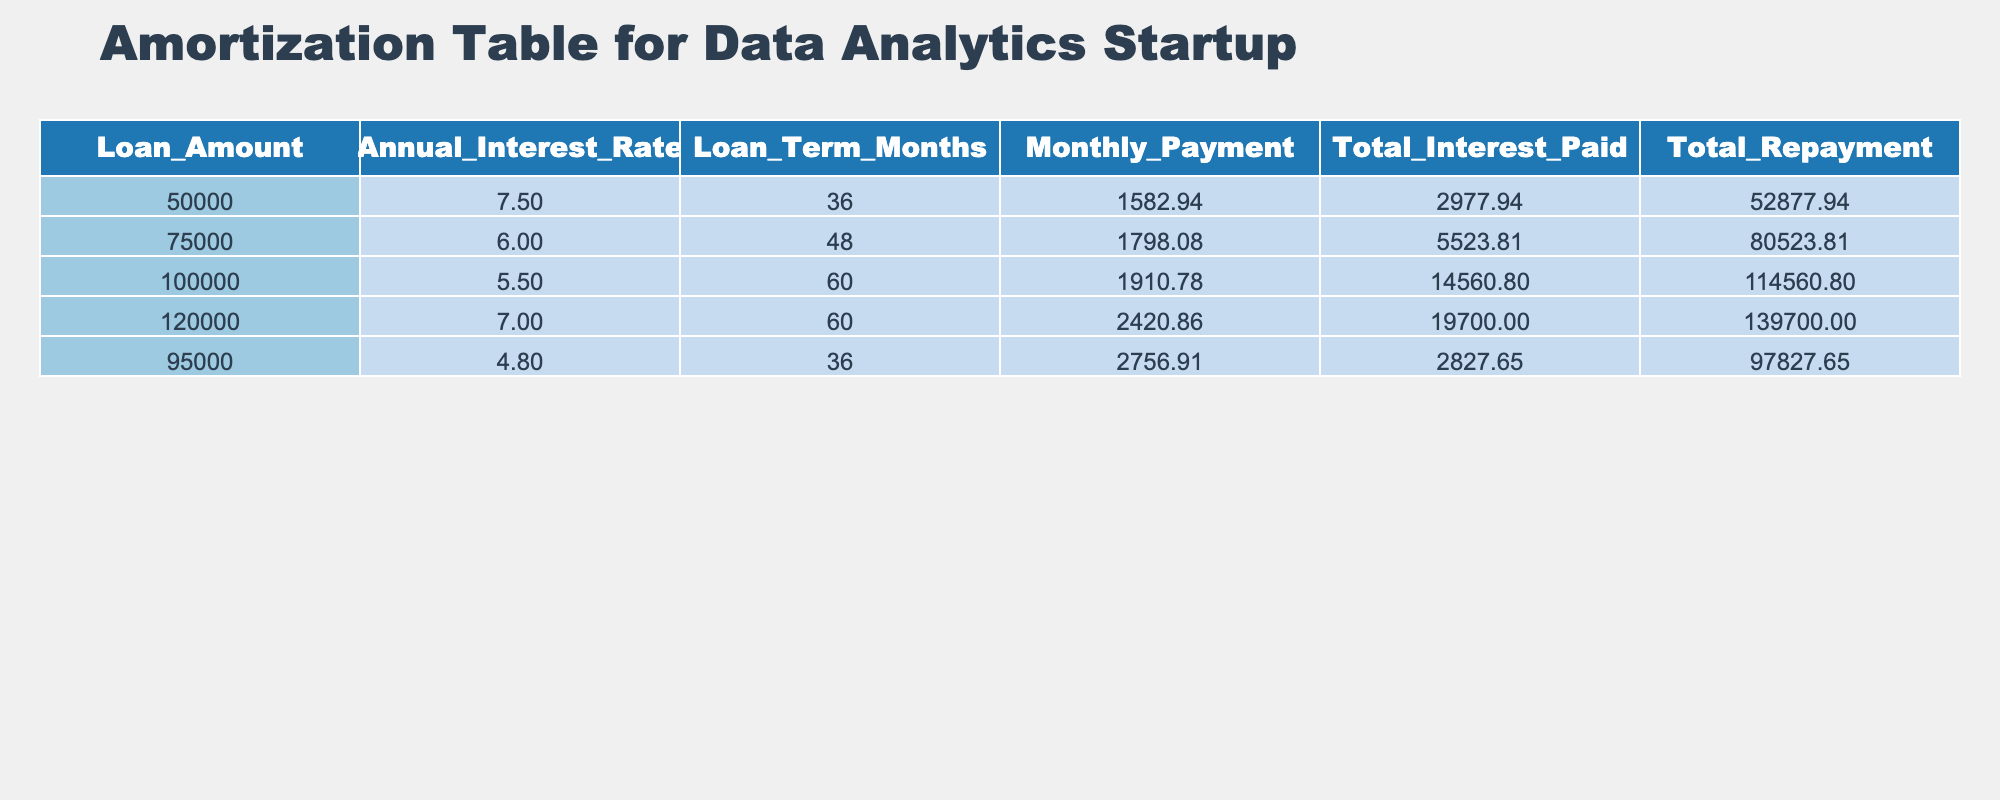What is the monthly payment for a loan amount of 100,000? The table clearly shows that the monthly payment for a loan amount of 100,000 is listed under the 'Monthly Payment' column for that specific row, which is 1910.78.
Answer: 1910.78 What is the total interest paid for the loan amount of 75,000? The total interest paid for the loan amount of 75,000 can be found in the 'Total Interest Paid' column corresponding to that row, which is 5523.81.
Answer: 5523.81 Is the total repayment for the equipment financing of 120,000 greater than 130,000? Comparing the total repayment for the loan amount of 120,000 in the table, which is 139700.00, it is evident that this amount is indeed greater than 130,000.
Answer: Yes Which loan has the lowest monthly payment? By examining the 'Monthly Payment' column, the lowest value is 1582.94 associated with the loan amount of 50,000. This is determined by comparing all entries in that column.
Answer: 1582.94 What is the average total repayment amount for all loans listed? To find the average total repayment amount, sum all the total repayments: 52877.94 + 80523.81 + 114560.80 + 139700.00 + 97827.65 = 485690.20. Then divide that sum by the number of loans, which is 5. So, 485690.20 / 5 = 97138.04.
Answer: 97138.04 Which loan has the highest total interest paid, and what is that amount? By inspecting the 'Total Interest Paid' column, the highest value is 19700.00 for the loan amount of 120,000. This is identified by finding the maximum value in that column.
Answer: 19700.00 Is it true that all loans have monthly payments over 1500? To verify, we check the 'Monthly Payment' column for each loan. The lowest monthly payment is 1582.94, which confirms that all listed loans indeed have monthly payments over 1500.
Answer: Yes What is the difference in total repayment between the loans of 50,000 and 120,000? The total repayment for 50,000 is 52877.94 and for 120,000 is 139700.00. To find the difference, subtract the former from the latter: 139700.00 - 52877.94 = 86822.06.
Answer: 86822.06 What is the total of all monthly payments for the loans listed? The total of all monthly payments can be calculated by summing each monthly payment: 1582.94 + 1798.08 + 1910.78 + 2420.86 + 2756.91 = 10469.57.
Answer: 10469.57 